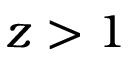Convert formula to latex. <formula><loc_0><loc_0><loc_500><loc_500>z > 1</formula> 